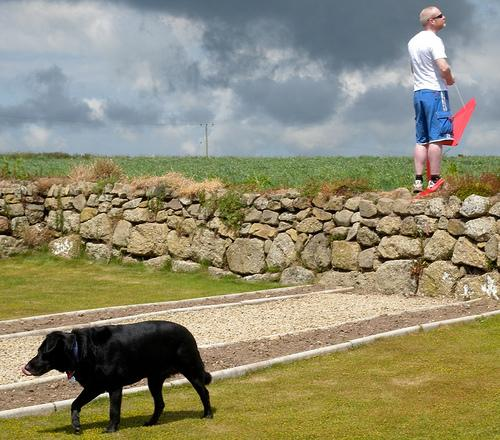What is the flag made of? plastic 